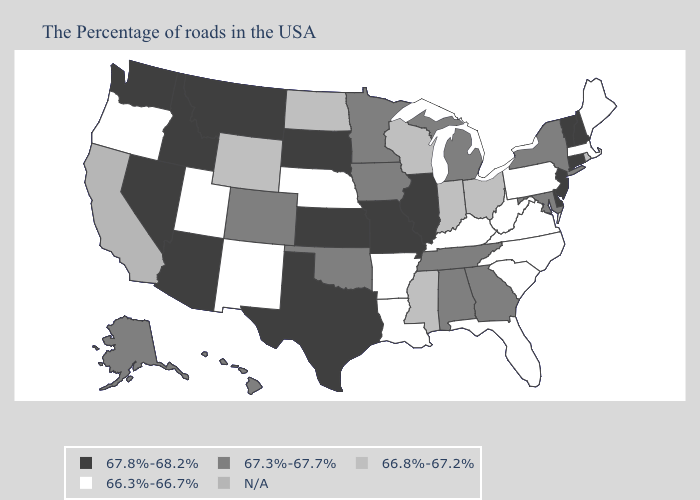What is the value of Rhode Island?
Concise answer only. 66.8%-67.2%. Name the states that have a value in the range 67.3%-67.7%?
Answer briefly. New York, Maryland, Georgia, Michigan, Alabama, Tennessee, Minnesota, Iowa, Oklahoma, Colorado, Alaska, Hawaii. Name the states that have a value in the range 67.8%-68.2%?
Short answer required. New Hampshire, Vermont, Connecticut, New Jersey, Delaware, Illinois, Missouri, Kansas, Texas, South Dakota, Montana, Arizona, Idaho, Nevada, Washington. Name the states that have a value in the range 66.8%-67.2%?
Answer briefly. Rhode Island, Ohio, Indiana, Wisconsin, Mississippi, North Dakota, Wyoming. What is the lowest value in the South?
Short answer required. 66.3%-66.7%. Which states have the highest value in the USA?
Short answer required. New Hampshire, Vermont, Connecticut, New Jersey, Delaware, Illinois, Missouri, Kansas, Texas, South Dakota, Montana, Arizona, Idaho, Nevada, Washington. Name the states that have a value in the range 67.8%-68.2%?
Keep it brief. New Hampshire, Vermont, Connecticut, New Jersey, Delaware, Illinois, Missouri, Kansas, Texas, South Dakota, Montana, Arizona, Idaho, Nevada, Washington. What is the lowest value in the USA?
Short answer required. 66.3%-66.7%. Name the states that have a value in the range 67.8%-68.2%?
Write a very short answer. New Hampshire, Vermont, Connecticut, New Jersey, Delaware, Illinois, Missouri, Kansas, Texas, South Dakota, Montana, Arizona, Idaho, Nevada, Washington. What is the lowest value in the USA?
Quick response, please. 66.3%-66.7%. Does the first symbol in the legend represent the smallest category?
Keep it brief. No. Name the states that have a value in the range 67.8%-68.2%?
Write a very short answer. New Hampshire, Vermont, Connecticut, New Jersey, Delaware, Illinois, Missouri, Kansas, Texas, South Dakota, Montana, Arizona, Idaho, Nevada, Washington. What is the highest value in the South ?
Write a very short answer. 67.8%-68.2%. What is the highest value in states that border New Jersey?
Keep it brief. 67.8%-68.2%. Name the states that have a value in the range 67.3%-67.7%?
Keep it brief. New York, Maryland, Georgia, Michigan, Alabama, Tennessee, Minnesota, Iowa, Oklahoma, Colorado, Alaska, Hawaii. 